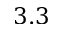Convert formula to latex. <formula><loc_0><loc_0><loc_500><loc_500>3 . 3</formula> 